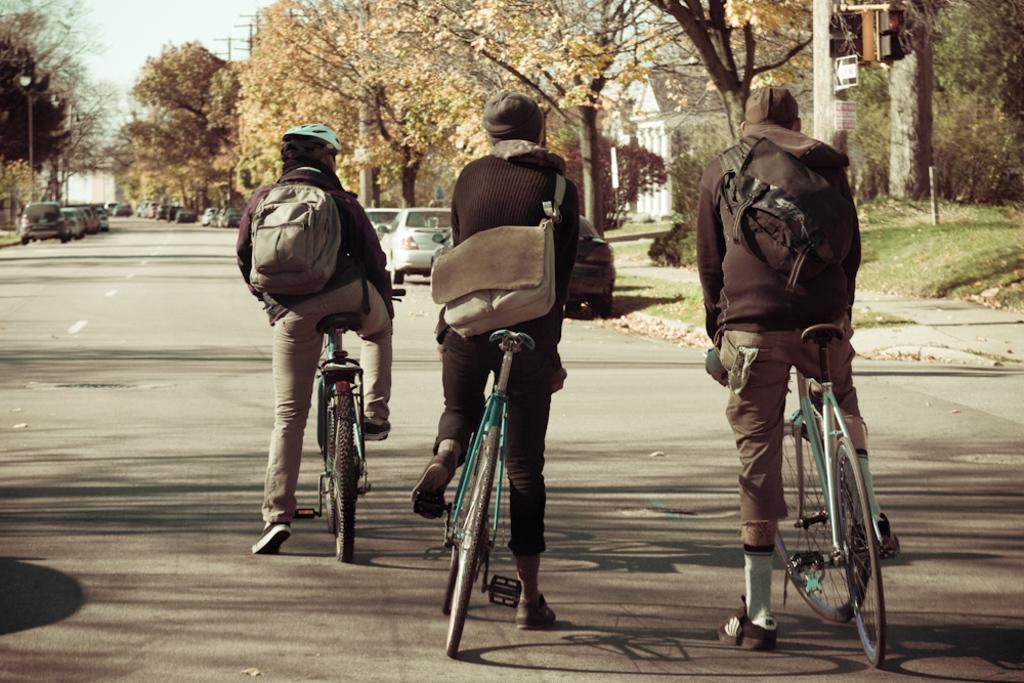How many people are in the image? There are three people in the image. What are the people doing in the image? The people are sitting on a bicycle. Where is the bicycle located? The bicycle is on the road. What can be seen in the background of the image? There are trees and parked cars in the background of the image. What type of garden can be seen in the image? There is no garden present in the image; it features three people sitting on a bicycle on the road, with trees and parked cars in the background. 